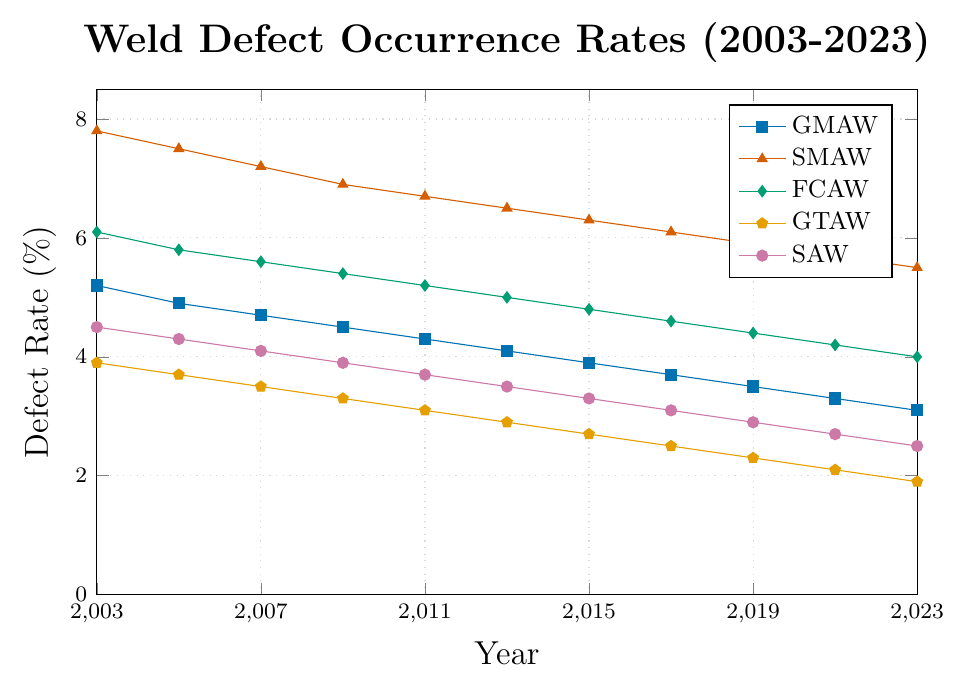Which welding process had the highest defect rate in 2003? In 2003, the SMAW process had the highest defect rate of 7.8% compared to the other processes.
Answer: SMAW Which welding process showed the largest decrease in defect rate from 2003 to 2023? From 2003 to 2023, the SMAW process showed the largest decrease in defect rate, dropping from 7.8% to 5.5%, a decrease of 2.3%.
Answer: SMAW What was the average defect rate for GMAW from 2003 to 2023? The defect rates for GMAW over the years 2003-2023 are: 5.2, 4.9, 4.7, 4.5, 4.3, 4.1, 3.9, 3.7, 3.5, 3.3, 3.1. Summing these values gives 45.2, and dividing by 11 (the number of years) gives an average of 4.11%.
Answer: 4.11% Compare the defect rates of GMAW and GTAW in 2023. Which one is lower? In 2023, the defect rate for GMAW is 3.1%, while for GTAW it is 1.9%. Thus, GTAW has a lower defect rate.
Answer: GTAW What is the difference in defect rates between SMAW and SAW in 2009? In 2009, the defect rate for SMAW is 6.9% and for SAW it is 3.9%. The difference is 6.9% - 3.9% = 3.0%.
Answer: 3.0% Identify the year when FCAW had a defect rate of 4.4%. The defect rate for FCAW is 4.4% in the year 2019, based on the data provided.
Answer: 2019 Sum the defect rates of all welding processes for the year 2011. The defect rates for 2011 are: GMAW (4.3%), SMAW (6.7%), FCAW (5.2%), GTAW (3.1%), SAW (3.7%). Summing these up gives 4.3 + 6.7 + 5.2 + 3.1 + 3.7 = 23.0%.
Answer: 23.0% How has the defect rate for GTAW changed from 2003 to 2013? In 2003, the defect rate for GTAW was 3.9%. In 2013, it was 2.9%. The change is 3.9% - 2.9% = 1.0%.
Answer: Decreased by 1.0% Which process had the most consistent decrease in defect rates over the years? Looking at the trends, GMAW had a consistent decrease from 5.2% in 2003 to 3.1% in 2023. Each subsequent point shows a decrease in defect rate.
Answer: GMAW 